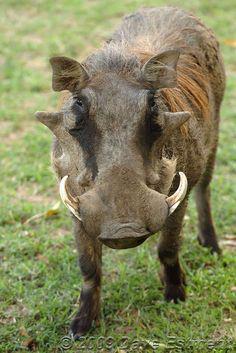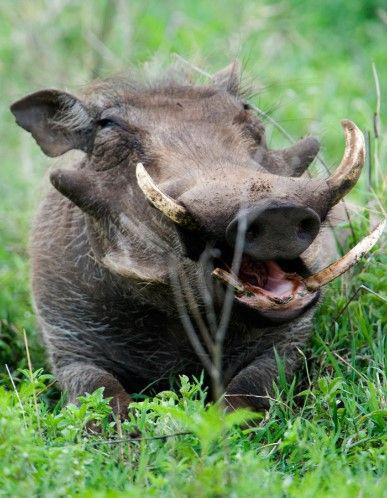The first image is the image on the left, the second image is the image on the right. Assess this claim about the two images: "The warthog in the image on the left is facing the camera.". Correct or not? Answer yes or no. Yes. 